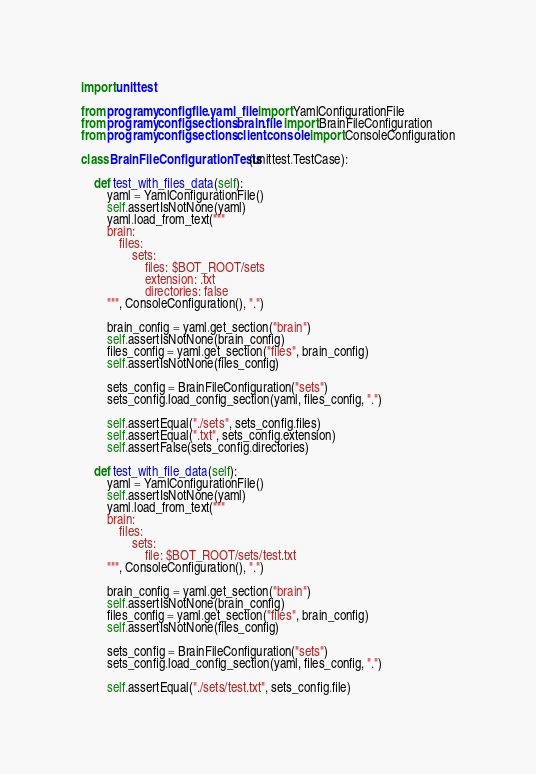<code> <loc_0><loc_0><loc_500><loc_500><_Python_>import unittest

from programy.config.file.yaml_file import YamlConfigurationFile
from programy.config.sections.brain.file import BrainFileConfiguration
from programy.config.sections.client.console import ConsoleConfiguration

class BrainFileConfigurationTests(unittest.TestCase):

    def test_with_files_data(self):
        yaml = YamlConfigurationFile()
        self.assertIsNotNone(yaml)
        yaml.load_from_text("""
        brain:
            files:
                sets:
                    files: $BOT_ROOT/sets
                    extension: .txt
                    directories: false
        """, ConsoleConfiguration(), ".")

        brain_config = yaml.get_section("brain")
        self.assertIsNotNone(brain_config)
        files_config = yaml.get_section("files", brain_config)
        self.assertIsNotNone(files_config)

        sets_config = BrainFileConfiguration("sets")
        sets_config.load_config_section(yaml, files_config, ".")

        self.assertEqual("./sets", sets_config.files)
        self.assertEqual(".txt", sets_config.extension)
        self.assertFalse(sets_config.directories)

    def test_with_file_data(self):
        yaml = YamlConfigurationFile()
        self.assertIsNotNone(yaml)
        yaml.load_from_text("""
        brain:
            files:
                sets:
                    file: $BOT_ROOT/sets/test.txt
        """, ConsoleConfiguration(), ".")

        brain_config = yaml.get_section("brain")
        self.assertIsNotNone(brain_config)
        files_config = yaml.get_section("files", brain_config)
        self.assertIsNotNone(files_config)

        sets_config = BrainFileConfiguration("sets")
        sets_config.load_config_section(yaml, files_config, ".")

        self.assertEqual("./sets/test.txt", sets_config.file)
</code> 